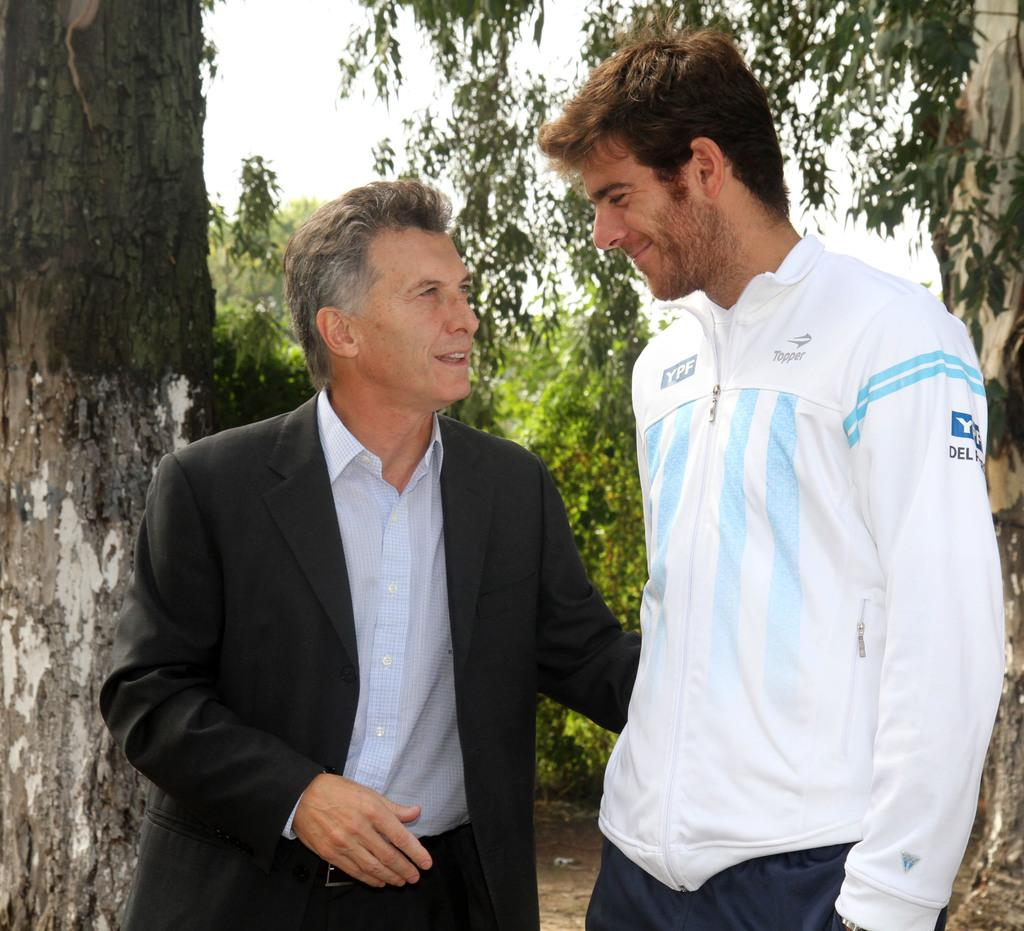How many people are in the image? There are two people in the image. Where are the two people located in the image? The two people are standing in the center of the image. What are the two people doing in the image? The two people are watching each other. What can be seen in the background of the image? There are trees visible in the background of the image. How is the background of the image depicted? The background is blurred. What type of branch is being used as a mode of transport by one of the people in the image? There is no branch or mode of transport present in the image; the two people are simply standing and watching each other. 